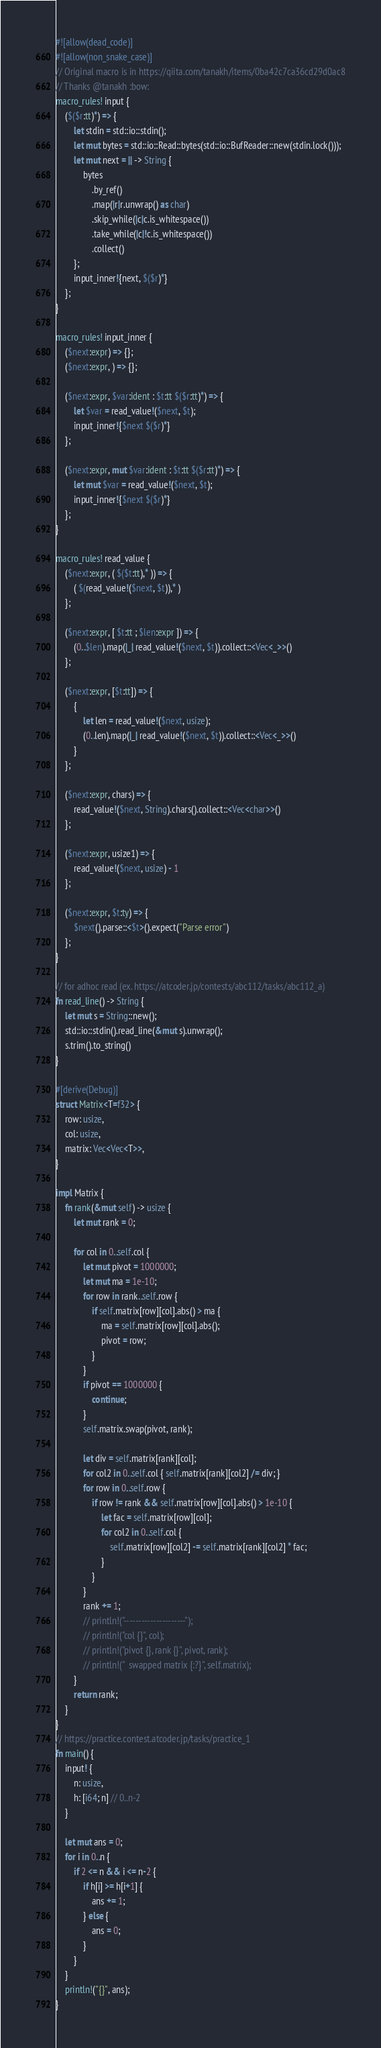<code> <loc_0><loc_0><loc_500><loc_500><_Rust_>#![allow(dead_code)]
#![allow(non_snake_case)]
// Original macro is in https://qiita.com/tanakh/items/0ba42c7ca36cd29d0ac8
// Thanks @tanakh :bow:
macro_rules! input {
    ($($r:tt)*) => {
        let stdin = std::io::stdin();
        let mut bytes = std::io::Read::bytes(std::io::BufReader::new(stdin.lock()));
        let mut next = || -> String {
            bytes
                .by_ref()
                .map(|r|r.unwrap() as char)
                .skip_while(|c|c.is_whitespace())
                .take_while(|c|!c.is_whitespace())
                .collect()
        };
        input_inner!{next, $($r)*}
    };
}
 
macro_rules! input_inner {
    ($next:expr) => {};
    ($next:expr, ) => {};
 
    ($next:expr, $var:ident : $t:tt $($r:tt)*) => {
        let $var = read_value!($next, $t);
        input_inner!{$next $($r)*}
    };
    
    ($next:expr, mut $var:ident : $t:tt $($r:tt)*) => {
        let mut $var = read_value!($next, $t);
        input_inner!{$next $($r)*}
    };
}
 
macro_rules! read_value {
    ($next:expr, ( $($t:tt),* )) => {
        ( $(read_value!($next, $t)),* )
    };
 
    ($next:expr, [ $t:tt ; $len:expr ]) => {
        (0..$len).map(|_| read_value!($next, $t)).collect::<Vec<_>>()
    };

    ($next:expr, [$t:tt]) => {
        {
            let len = read_value!($next, usize);
            (0..len).map(|_| read_value!($next, $t)).collect::<Vec<_>>()
        }
    };
 
    ($next:expr, chars) => {
        read_value!($next, String).chars().collect::<Vec<char>>()
    };
 
    ($next:expr, usize1) => {
        read_value!($next, usize) - 1
    };
 
    ($next:expr, $t:ty) => {
        $next().parse::<$t>().expect("Parse error")
    };
}

// for adhoc read (ex. https://atcoder.jp/contests/abc112/tasks/abc112_a)
fn read_line() -> String {
    let mut s = String::new();
    std::io::stdin().read_line(&mut s).unwrap();
    s.trim().to_string()
}

#[derive(Debug)]
struct Matrix<T=f32> {
    row: usize,
    col: usize,
    matrix: Vec<Vec<T>>,
}

impl Matrix {
    fn rank(&mut self) -> usize {
        let mut rank = 0;

        for col in 0..self.col {
            let mut pivot = 1000000;
            let mut ma = 1e-10;
            for row in rank..self.row {
                if self.matrix[row][col].abs() > ma {
                    ma = self.matrix[row][col].abs();
                    pivot = row;
                }
            }
            if pivot == 1000000 {
                continue;
            }
            self.matrix.swap(pivot, rank);

            let div = self.matrix[rank][col];
            for col2 in 0..self.col { self.matrix[rank][col2] /= div; }
            for row in 0..self.row {
                if row != rank && self.matrix[row][col].abs() > 1e-10 {
                    let fac = self.matrix[row][col];
                    for col2 in 0..self.col {
                        self.matrix[row][col2] -= self.matrix[rank][col2] * fac;
                    }
                }
            }
            rank += 1;
            // println!("---------------------");
            // println!("col {}", col);
            // println!("pivot {}, rank {}", pivot, rank);
            // println!("  swapped matrix {:?}", self.matrix);
        }
        return rank;
    }
}
// https://practice.contest.atcoder.jp/tasks/practice_1
fn main() {
    input! {
        n: usize,
        h: [i64; n] // 0..n-2
    }

    let mut ans = 0;
    for i in 0..n {
        if 2 <= n && i <= n-2 {
            if h[i] >= h[i+1] {
                ans += 1;
            } else {
                ans = 0;
            }
        }
    }
    println!("{}", ans);
}
</code> 